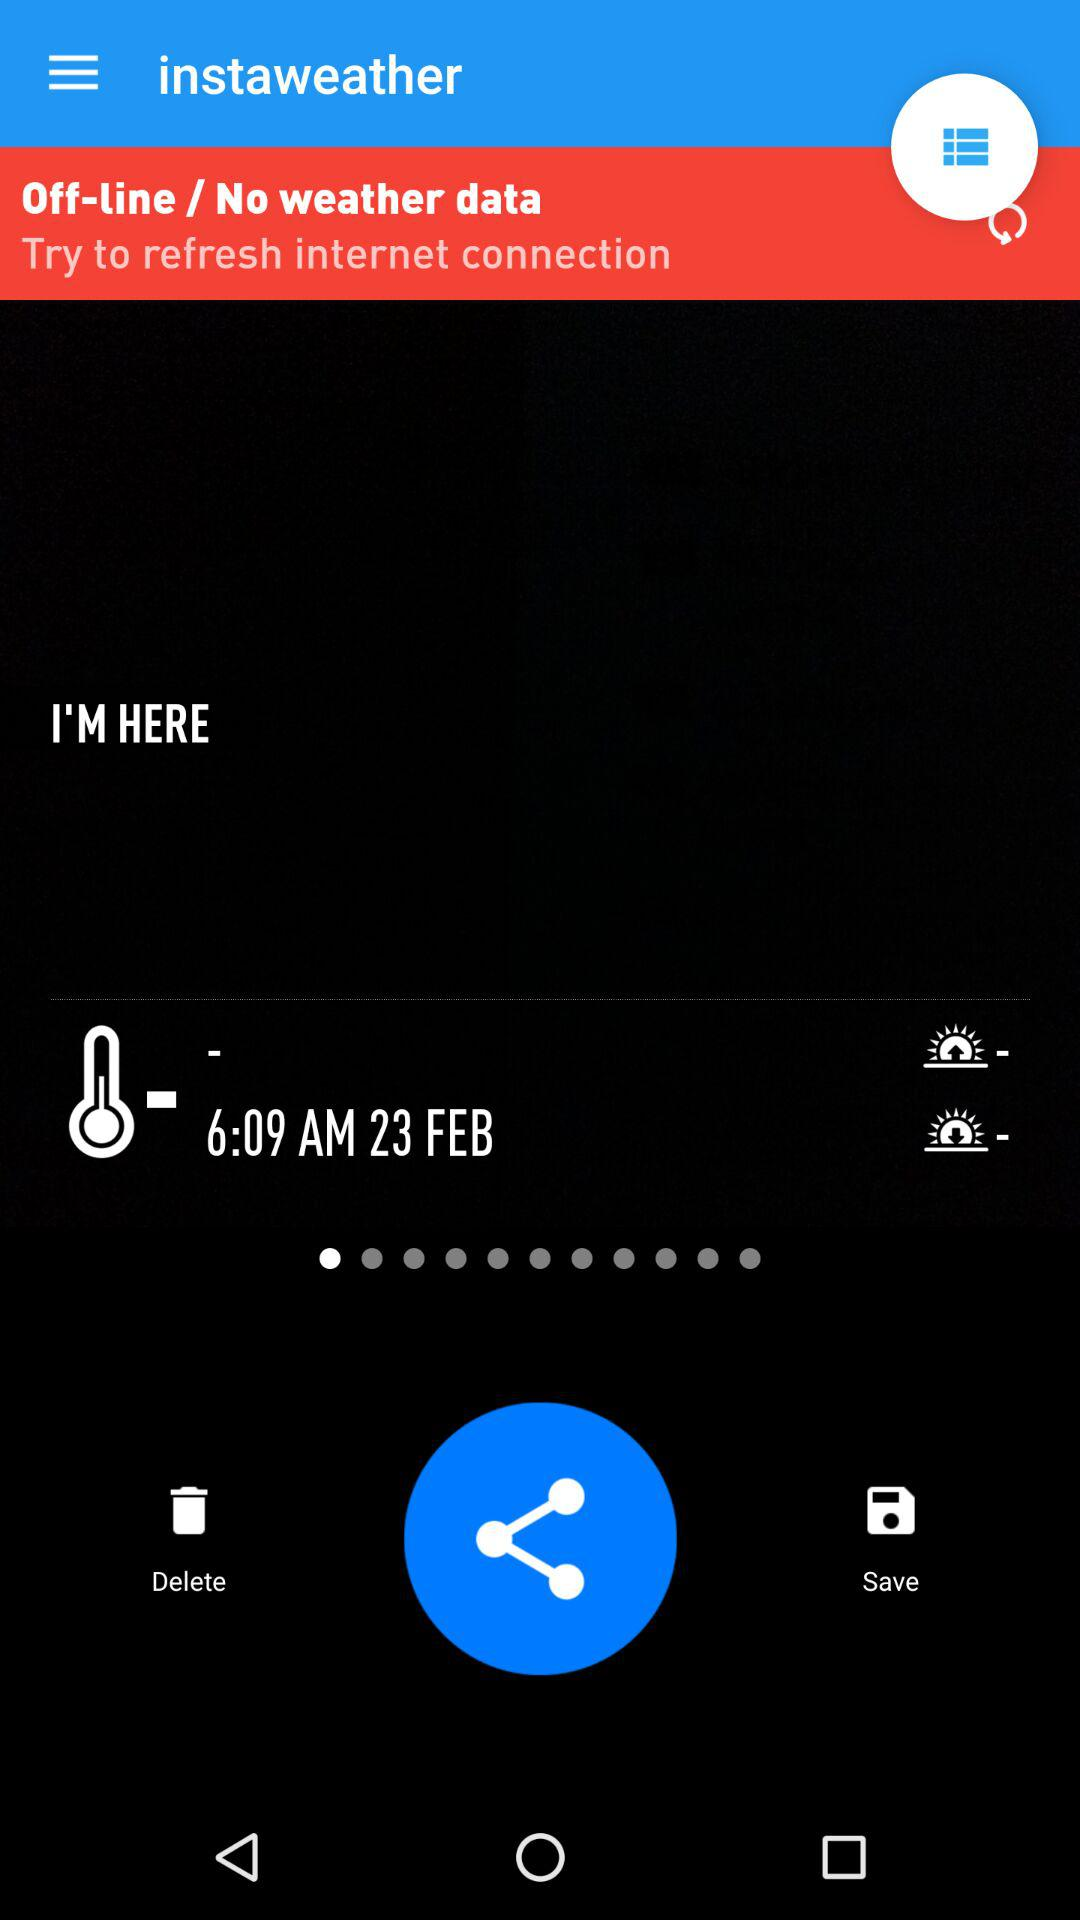Is there any weather data? There is no weather data present. 